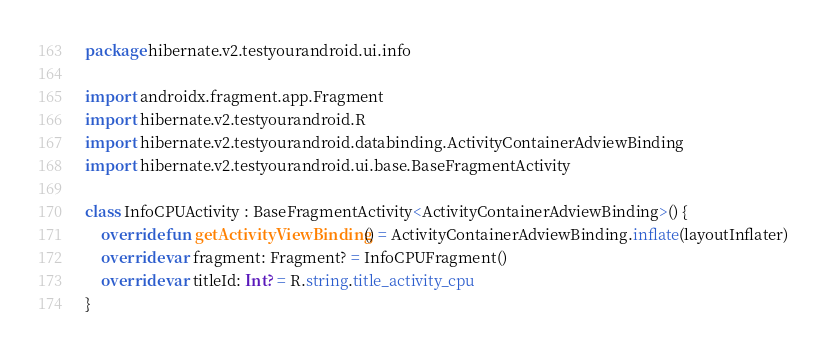<code> <loc_0><loc_0><loc_500><loc_500><_Kotlin_>package hibernate.v2.testyourandroid.ui.info

import androidx.fragment.app.Fragment
import hibernate.v2.testyourandroid.R
import hibernate.v2.testyourandroid.databinding.ActivityContainerAdviewBinding
import hibernate.v2.testyourandroid.ui.base.BaseFragmentActivity

class InfoCPUActivity : BaseFragmentActivity<ActivityContainerAdviewBinding>() {
    override fun getActivityViewBinding() = ActivityContainerAdviewBinding.inflate(layoutInflater)
    override var fragment: Fragment? = InfoCPUFragment()
    override var titleId: Int? = R.string.title_activity_cpu
}</code> 